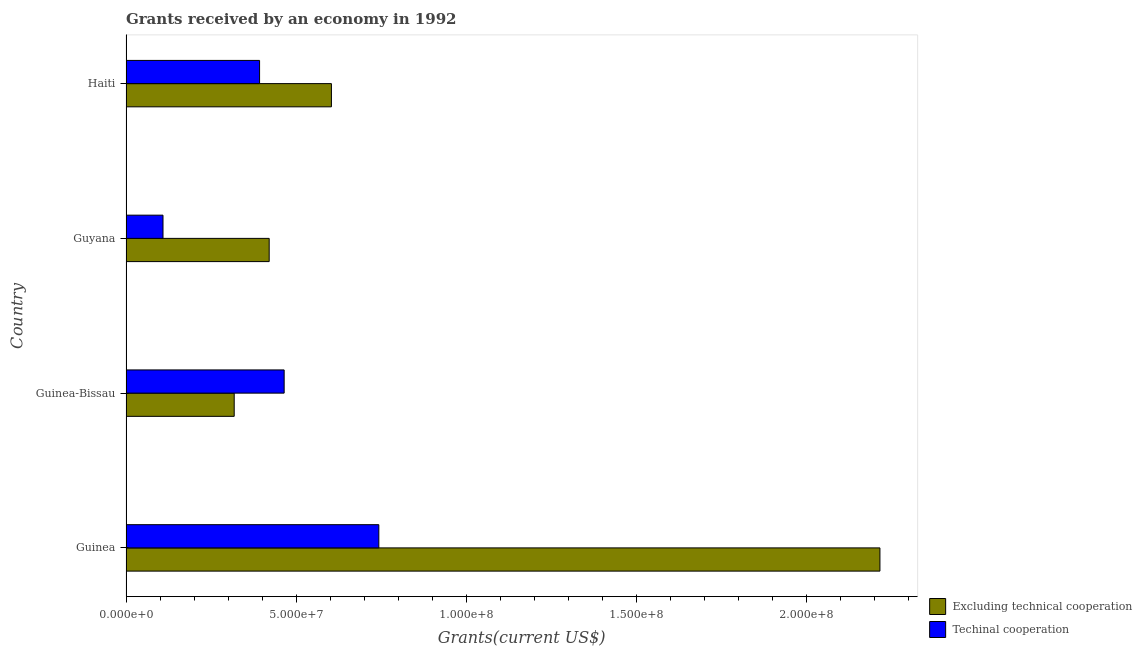How many different coloured bars are there?
Provide a succinct answer. 2. Are the number of bars per tick equal to the number of legend labels?
Your answer should be compact. Yes. How many bars are there on the 3rd tick from the bottom?
Provide a succinct answer. 2. What is the label of the 3rd group of bars from the top?
Your answer should be very brief. Guinea-Bissau. What is the amount of grants received(excluding technical cooperation) in Guinea-Bissau?
Provide a succinct answer. 3.18e+07. Across all countries, what is the maximum amount of grants received(including technical cooperation)?
Provide a succinct answer. 7.43e+07. Across all countries, what is the minimum amount of grants received(excluding technical cooperation)?
Provide a succinct answer. 3.18e+07. In which country was the amount of grants received(including technical cooperation) maximum?
Your answer should be very brief. Guinea. In which country was the amount of grants received(excluding technical cooperation) minimum?
Provide a short and direct response. Guinea-Bissau. What is the total amount of grants received(including technical cooperation) in the graph?
Provide a short and direct response. 1.71e+08. What is the difference between the amount of grants received(excluding technical cooperation) in Guinea-Bissau and that in Guyana?
Your response must be concise. -1.03e+07. What is the difference between the amount of grants received(excluding technical cooperation) in Guyana and the amount of grants received(including technical cooperation) in Guinea?
Offer a terse response. -3.22e+07. What is the average amount of grants received(excluding technical cooperation) per country?
Offer a very short reply. 8.89e+07. What is the difference between the amount of grants received(excluding technical cooperation) and amount of grants received(including technical cooperation) in Haiti?
Your response must be concise. 2.11e+07. What is the ratio of the amount of grants received(including technical cooperation) in Guinea-Bissau to that in Haiti?
Your answer should be very brief. 1.18. Is the difference between the amount of grants received(excluding technical cooperation) in Guinea and Guinea-Bissau greater than the difference between the amount of grants received(including technical cooperation) in Guinea and Guinea-Bissau?
Offer a terse response. Yes. What is the difference between the highest and the second highest amount of grants received(excluding technical cooperation)?
Offer a very short reply. 1.61e+08. What is the difference between the highest and the lowest amount of grants received(excluding technical cooperation)?
Your answer should be compact. 1.90e+08. In how many countries, is the amount of grants received(including technical cooperation) greater than the average amount of grants received(including technical cooperation) taken over all countries?
Ensure brevity in your answer.  2. What does the 1st bar from the top in Haiti represents?
Offer a very short reply. Techinal cooperation. What does the 1st bar from the bottom in Guyana represents?
Give a very brief answer. Excluding technical cooperation. What is the difference between two consecutive major ticks on the X-axis?
Provide a short and direct response. 5.00e+07. Are the values on the major ticks of X-axis written in scientific E-notation?
Provide a succinct answer. Yes. Where does the legend appear in the graph?
Give a very brief answer. Bottom right. How many legend labels are there?
Offer a very short reply. 2. What is the title of the graph?
Offer a very short reply. Grants received by an economy in 1992. Does "Merchandise exports" appear as one of the legend labels in the graph?
Your answer should be compact. No. What is the label or title of the X-axis?
Keep it short and to the point. Grants(current US$). What is the label or title of the Y-axis?
Keep it short and to the point. Country. What is the Grants(current US$) of Excluding technical cooperation in Guinea?
Keep it short and to the point. 2.22e+08. What is the Grants(current US$) in Techinal cooperation in Guinea?
Keep it short and to the point. 7.43e+07. What is the Grants(current US$) of Excluding technical cooperation in Guinea-Bissau?
Your response must be concise. 3.18e+07. What is the Grants(current US$) of Techinal cooperation in Guinea-Bissau?
Your response must be concise. 4.65e+07. What is the Grants(current US$) of Excluding technical cooperation in Guyana?
Ensure brevity in your answer.  4.21e+07. What is the Grants(current US$) in Techinal cooperation in Guyana?
Give a very brief answer. 1.09e+07. What is the Grants(current US$) of Excluding technical cooperation in Haiti?
Make the answer very short. 6.04e+07. What is the Grants(current US$) of Techinal cooperation in Haiti?
Keep it short and to the point. 3.92e+07. Across all countries, what is the maximum Grants(current US$) in Excluding technical cooperation?
Offer a very short reply. 2.22e+08. Across all countries, what is the maximum Grants(current US$) in Techinal cooperation?
Your response must be concise. 7.43e+07. Across all countries, what is the minimum Grants(current US$) of Excluding technical cooperation?
Offer a very short reply. 3.18e+07. Across all countries, what is the minimum Grants(current US$) in Techinal cooperation?
Your answer should be compact. 1.09e+07. What is the total Grants(current US$) in Excluding technical cooperation in the graph?
Make the answer very short. 3.56e+08. What is the total Grants(current US$) of Techinal cooperation in the graph?
Ensure brevity in your answer.  1.71e+08. What is the difference between the Grants(current US$) in Excluding technical cooperation in Guinea and that in Guinea-Bissau?
Provide a succinct answer. 1.90e+08. What is the difference between the Grants(current US$) of Techinal cooperation in Guinea and that in Guinea-Bissau?
Ensure brevity in your answer.  2.78e+07. What is the difference between the Grants(current US$) of Excluding technical cooperation in Guinea and that in Guyana?
Offer a terse response. 1.79e+08. What is the difference between the Grants(current US$) in Techinal cooperation in Guinea and that in Guyana?
Your answer should be compact. 6.34e+07. What is the difference between the Grants(current US$) in Excluding technical cooperation in Guinea and that in Haiti?
Your answer should be compact. 1.61e+08. What is the difference between the Grants(current US$) in Techinal cooperation in Guinea and that in Haiti?
Give a very brief answer. 3.50e+07. What is the difference between the Grants(current US$) in Excluding technical cooperation in Guinea-Bissau and that in Guyana?
Your answer should be compact. -1.03e+07. What is the difference between the Grants(current US$) of Techinal cooperation in Guinea-Bissau and that in Guyana?
Provide a short and direct response. 3.56e+07. What is the difference between the Grants(current US$) of Excluding technical cooperation in Guinea-Bissau and that in Haiti?
Keep it short and to the point. -2.86e+07. What is the difference between the Grants(current US$) in Techinal cooperation in Guinea-Bissau and that in Haiti?
Provide a short and direct response. 7.22e+06. What is the difference between the Grants(current US$) of Excluding technical cooperation in Guyana and that in Haiti?
Ensure brevity in your answer.  -1.83e+07. What is the difference between the Grants(current US$) in Techinal cooperation in Guyana and that in Haiti?
Ensure brevity in your answer.  -2.84e+07. What is the difference between the Grants(current US$) of Excluding technical cooperation in Guinea and the Grants(current US$) of Techinal cooperation in Guinea-Bissau?
Offer a terse response. 1.75e+08. What is the difference between the Grants(current US$) in Excluding technical cooperation in Guinea and the Grants(current US$) in Techinal cooperation in Guyana?
Your answer should be very brief. 2.11e+08. What is the difference between the Grants(current US$) of Excluding technical cooperation in Guinea and the Grants(current US$) of Techinal cooperation in Haiti?
Your answer should be compact. 1.82e+08. What is the difference between the Grants(current US$) of Excluding technical cooperation in Guinea-Bissau and the Grants(current US$) of Techinal cooperation in Guyana?
Make the answer very short. 2.09e+07. What is the difference between the Grants(current US$) of Excluding technical cooperation in Guinea-Bissau and the Grants(current US$) of Techinal cooperation in Haiti?
Your response must be concise. -7.46e+06. What is the difference between the Grants(current US$) of Excluding technical cooperation in Guyana and the Grants(current US$) of Techinal cooperation in Haiti?
Make the answer very short. 2.82e+06. What is the average Grants(current US$) in Excluding technical cooperation per country?
Ensure brevity in your answer.  8.89e+07. What is the average Grants(current US$) of Techinal cooperation per country?
Make the answer very short. 4.27e+07. What is the difference between the Grants(current US$) of Excluding technical cooperation and Grants(current US$) of Techinal cooperation in Guinea?
Your answer should be compact. 1.47e+08. What is the difference between the Grants(current US$) of Excluding technical cooperation and Grants(current US$) of Techinal cooperation in Guinea-Bissau?
Keep it short and to the point. -1.47e+07. What is the difference between the Grants(current US$) of Excluding technical cooperation and Grants(current US$) of Techinal cooperation in Guyana?
Ensure brevity in your answer.  3.12e+07. What is the difference between the Grants(current US$) in Excluding technical cooperation and Grants(current US$) in Techinal cooperation in Haiti?
Make the answer very short. 2.11e+07. What is the ratio of the Grants(current US$) of Excluding technical cooperation in Guinea to that in Guinea-Bissau?
Your answer should be compact. 6.97. What is the ratio of the Grants(current US$) in Techinal cooperation in Guinea to that in Guinea-Bissau?
Offer a terse response. 1.6. What is the ratio of the Grants(current US$) of Excluding technical cooperation in Guinea to that in Guyana?
Provide a succinct answer. 5.27. What is the ratio of the Grants(current US$) in Techinal cooperation in Guinea to that in Guyana?
Provide a succinct answer. 6.83. What is the ratio of the Grants(current US$) of Excluding technical cooperation in Guinea to that in Haiti?
Offer a very short reply. 3.67. What is the ratio of the Grants(current US$) of Techinal cooperation in Guinea to that in Haiti?
Ensure brevity in your answer.  1.89. What is the ratio of the Grants(current US$) of Excluding technical cooperation in Guinea-Bissau to that in Guyana?
Make the answer very short. 0.76. What is the ratio of the Grants(current US$) in Techinal cooperation in Guinea-Bissau to that in Guyana?
Make the answer very short. 4.28. What is the ratio of the Grants(current US$) of Excluding technical cooperation in Guinea-Bissau to that in Haiti?
Your answer should be very brief. 0.53. What is the ratio of the Grants(current US$) of Techinal cooperation in Guinea-Bissau to that in Haiti?
Your response must be concise. 1.18. What is the ratio of the Grants(current US$) in Excluding technical cooperation in Guyana to that in Haiti?
Keep it short and to the point. 0.7. What is the ratio of the Grants(current US$) of Techinal cooperation in Guyana to that in Haiti?
Your response must be concise. 0.28. What is the difference between the highest and the second highest Grants(current US$) of Excluding technical cooperation?
Offer a very short reply. 1.61e+08. What is the difference between the highest and the second highest Grants(current US$) in Techinal cooperation?
Provide a succinct answer. 2.78e+07. What is the difference between the highest and the lowest Grants(current US$) in Excluding technical cooperation?
Provide a short and direct response. 1.90e+08. What is the difference between the highest and the lowest Grants(current US$) in Techinal cooperation?
Offer a terse response. 6.34e+07. 